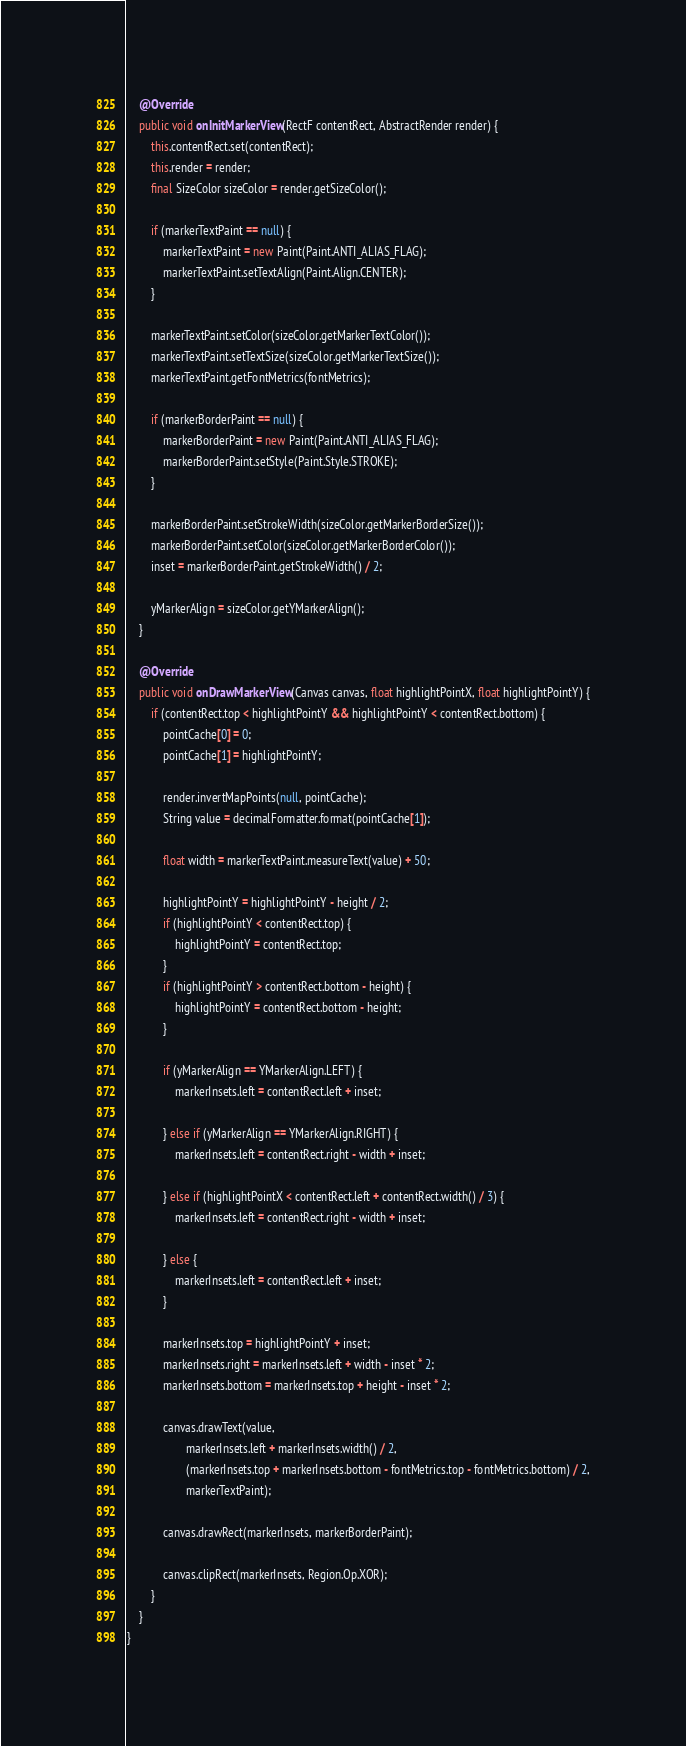<code> <loc_0><loc_0><loc_500><loc_500><_Java_>
    @Override
    public void onInitMarkerView(RectF contentRect, AbstractRender render) {
        this.contentRect.set(contentRect);
        this.render = render;
        final SizeColor sizeColor = render.getSizeColor();

        if (markerTextPaint == null) {
            markerTextPaint = new Paint(Paint.ANTI_ALIAS_FLAG);
            markerTextPaint.setTextAlign(Paint.Align.CENTER);
        }

        markerTextPaint.setColor(sizeColor.getMarkerTextColor());
        markerTextPaint.setTextSize(sizeColor.getMarkerTextSize());
        markerTextPaint.getFontMetrics(fontMetrics);

        if (markerBorderPaint == null) {
            markerBorderPaint = new Paint(Paint.ANTI_ALIAS_FLAG);
            markerBorderPaint.setStyle(Paint.Style.STROKE);
        }

        markerBorderPaint.setStrokeWidth(sizeColor.getMarkerBorderSize());
        markerBorderPaint.setColor(sizeColor.getMarkerBorderColor());
        inset = markerBorderPaint.getStrokeWidth() / 2;

        yMarkerAlign = sizeColor.getYMarkerAlign();
    }

    @Override
    public void onDrawMarkerView(Canvas canvas, float highlightPointX, float highlightPointY) {
        if (contentRect.top < highlightPointY && highlightPointY < contentRect.bottom) {
            pointCache[0] = 0;
            pointCache[1] = highlightPointY;

            render.invertMapPoints(null, pointCache);
            String value = decimalFormatter.format(pointCache[1]);

            float width = markerTextPaint.measureText(value) + 50;

            highlightPointY = highlightPointY - height / 2;
            if (highlightPointY < contentRect.top) {
                highlightPointY = contentRect.top;
            }
            if (highlightPointY > contentRect.bottom - height) {
                highlightPointY = contentRect.bottom - height;
            }

            if (yMarkerAlign == YMarkerAlign.LEFT) {
                markerInsets.left = contentRect.left + inset;

            } else if (yMarkerAlign == YMarkerAlign.RIGHT) {
                markerInsets.left = contentRect.right - width + inset;

            } else if (highlightPointX < contentRect.left + contentRect.width() / 3) {
                markerInsets.left = contentRect.right - width + inset;

            } else {
                markerInsets.left = contentRect.left + inset;
            }

            markerInsets.top = highlightPointY + inset;
            markerInsets.right = markerInsets.left + width - inset * 2;
            markerInsets.bottom = markerInsets.top + height - inset * 2;

            canvas.drawText(value,
                    markerInsets.left + markerInsets.width() / 2,
                    (markerInsets.top + markerInsets.bottom - fontMetrics.top - fontMetrics.bottom) / 2,
                    markerTextPaint);

            canvas.drawRect(markerInsets, markerBorderPaint);

            canvas.clipRect(markerInsets, Region.Op.XOR);
        }
    }
}
</code> 